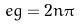Convert formula to latex. <formula><loc_0><loc_0><loc_500><loc_500>e g = 2 n \pi</formula> 